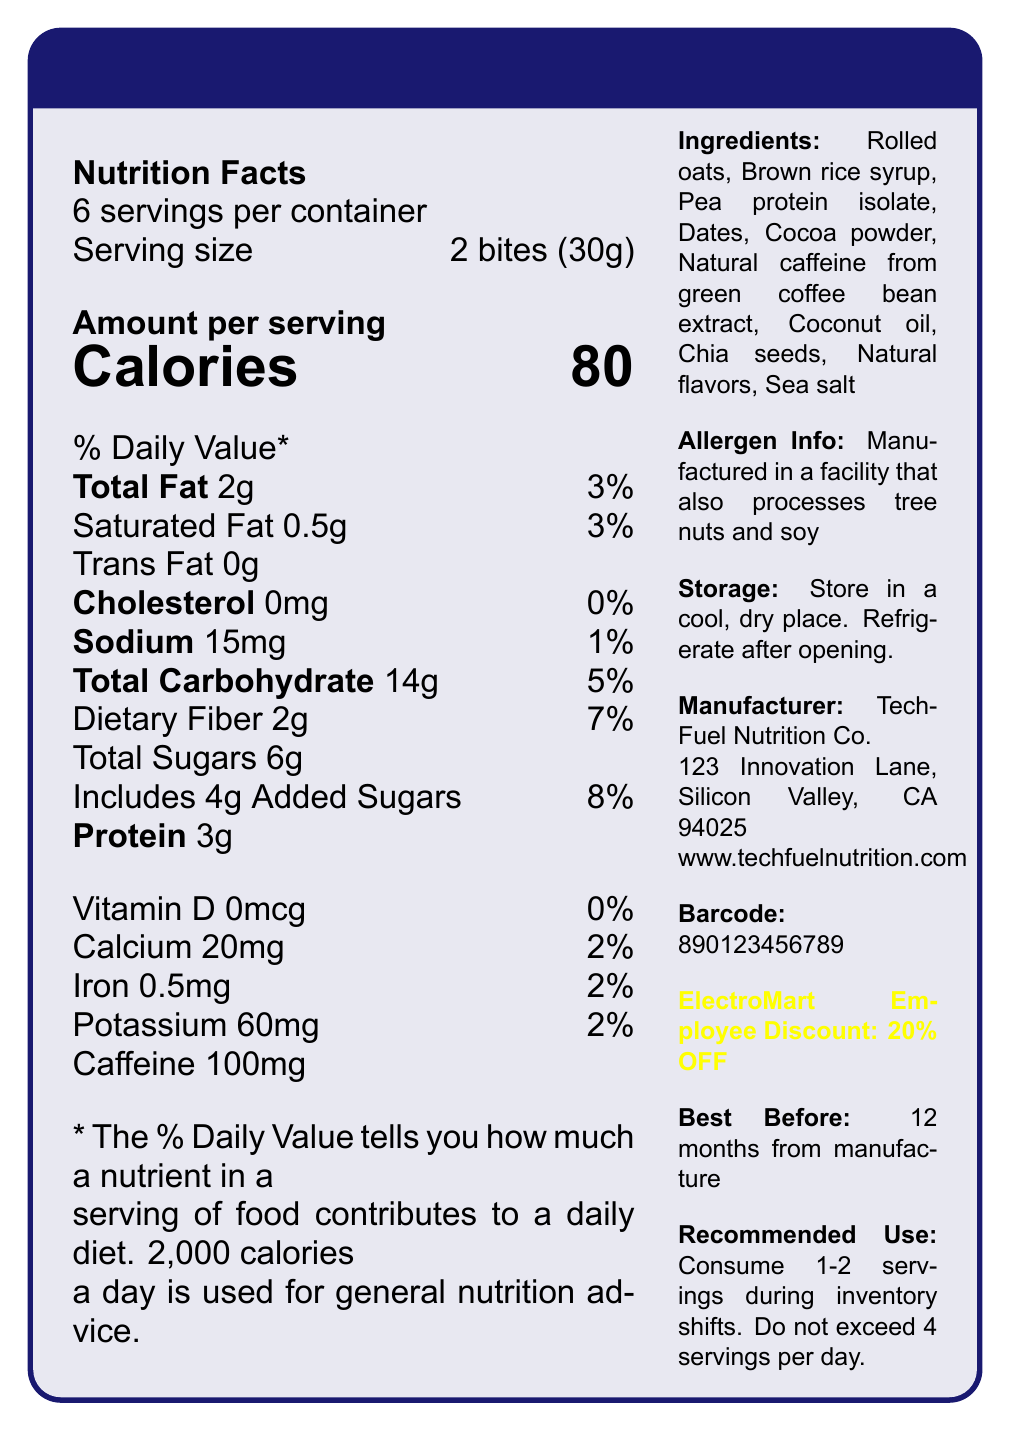what is the serving size of NightShift Energy Bites? The serving size is explicitly mentioned in the document as "2 bites (30g)".
Answer: 2 bites (30g) how many calories are in one serving of NightShift Energy Bites? The document clearly states that there are 80 calories per serving.
Answer: 80 how many servings are there in one container of NightShift Energy Bites? The document specifies that there are 6 servings per container.
Answer: 6 how much total fat is in one serving? The nutrition facts section shows that there are 2g of total fat per serving.
Answer: 2g how much caffeine is in one serving? The document states that each serving contains 100mg of caffeine.
Answer: 100mg how much dietary fiber is in one serving? A. 1g B. 2g C. 3g D. 4g The document mentions that there are 2g of dietary fiber per serving.
Answer: B. 2g what is the daily value percentage of added sugars per serving? A. 3% B. 5% C. 7% D. 8% The document shows that the daily value percentage for added sugars is 8%.
Answer: D. 8% is NightShift Energy Bites a low-fat snack? The document shows that one serving contains 2g of total fat, which is 3% of the daily value, classifying it as low-fat.
Answer: Yes was the product manufactured in a facility that processes tree nuts? The allergen info states that it is manufactured in a facility that also processes tree nuts and soy.
Answer: Yes can the exact date of manufacture be determined from the document? The document provides only the shelf life, indicating "12 months from manufacture," without providing the exact manufacture date.
Answer: Not enough information summarize the main idea of the document. The main idea of the document is to provide comprehensive nutritional information, usage instructions, and product benefits while highlighting its utility for late-night inventory tasks at an electronics store.
Answer: The document provides the nutrition facts and details for NightShift Energy Bites, a low-calorie, high-caffeine snack designed for late-night inventory shifts. Key highlights include its serving size, daily values of nutrients, ingredients, allergen info, and recommended use. It also provides additional benefits, storage instructions, and employee discount details. 